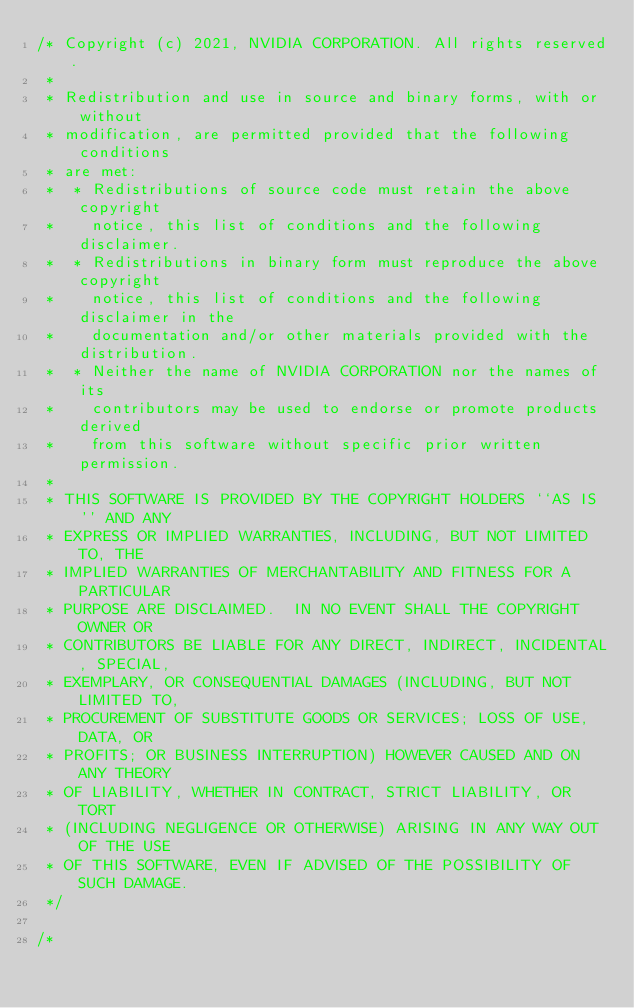Convert code to text. <code><loc_0><loc_0><loc_500><loc_500><_Cuda_>/* Copyright (c) 2021, NVIDIA CORPORATION. All rights reserved.
 *
 * Redistribution and use in source and binary forms, with or without
 * modification, are permitted provided that the following conditions
 * are met:
 *  * Redistributions of source code must retain the above copyright
 *    notice, this list of conditions and the following disclaimer.
 *  * Redistributions in binary form must reproduce the above copyright
 *    notice, this list of conditions and the following disclaimer in the
 *    documentation and/or other materials provided with the distribution.
 *  * Neither the name of NVIDIA CORPORATION nor the names of its
 *    contributors may be used to endorse or promote products derived
 *    from this software without specific prior written permission.
 *
 * THIS SOFTWARE IS PROVIDED BY THE COPYRIGHT HOLDERS ``AS IS'' AND ANY
 * EXPRESS OR IMPLIED WARRANTIES, INCLUDING, BUT NOT LIMITED TO, THE
 * IMPLIED WARRANTIES OF MERCHANTABILITY AND FITNESS FOR A PARTICULAR
 * PURPOSE ARE DISCLAIMED.  IN NO EVENT SHALL THE COPYRIGHT OWNER OR
 * CONTRIBUTORS BE LIABLE FOR ANY DIRECT, INDIRECT, INCIDENTAL, SPECIAL,
 * EXEMPLARY, OR CONSEQUENTIAL DAMAGES (INCLUDING, BUT NOT LIMITED TO,
 * PROCUREMENT OF SUBSTITUTE GOODS OR SERVICES; LOSS OF USE, DATA, OR
 * PROFITS; OR BUSINESS INTERRUPTION) HOWEVER CAUSED AND ON ANY THEORY
 * OF LIABILITY, WHETHER IN CONTRACT, STRICT LIABILITY, OR TORT
 * (INCLUDING NEGLIGENCE OR OTHERWISE) ARISING IN ANY WAY OUT OF THE USE
 * OF THIS SOFTWARE, EVEN IF ADVISED OF THE POSSIBILITY OF SUCH DAMAGE.
 */

/*</code> 